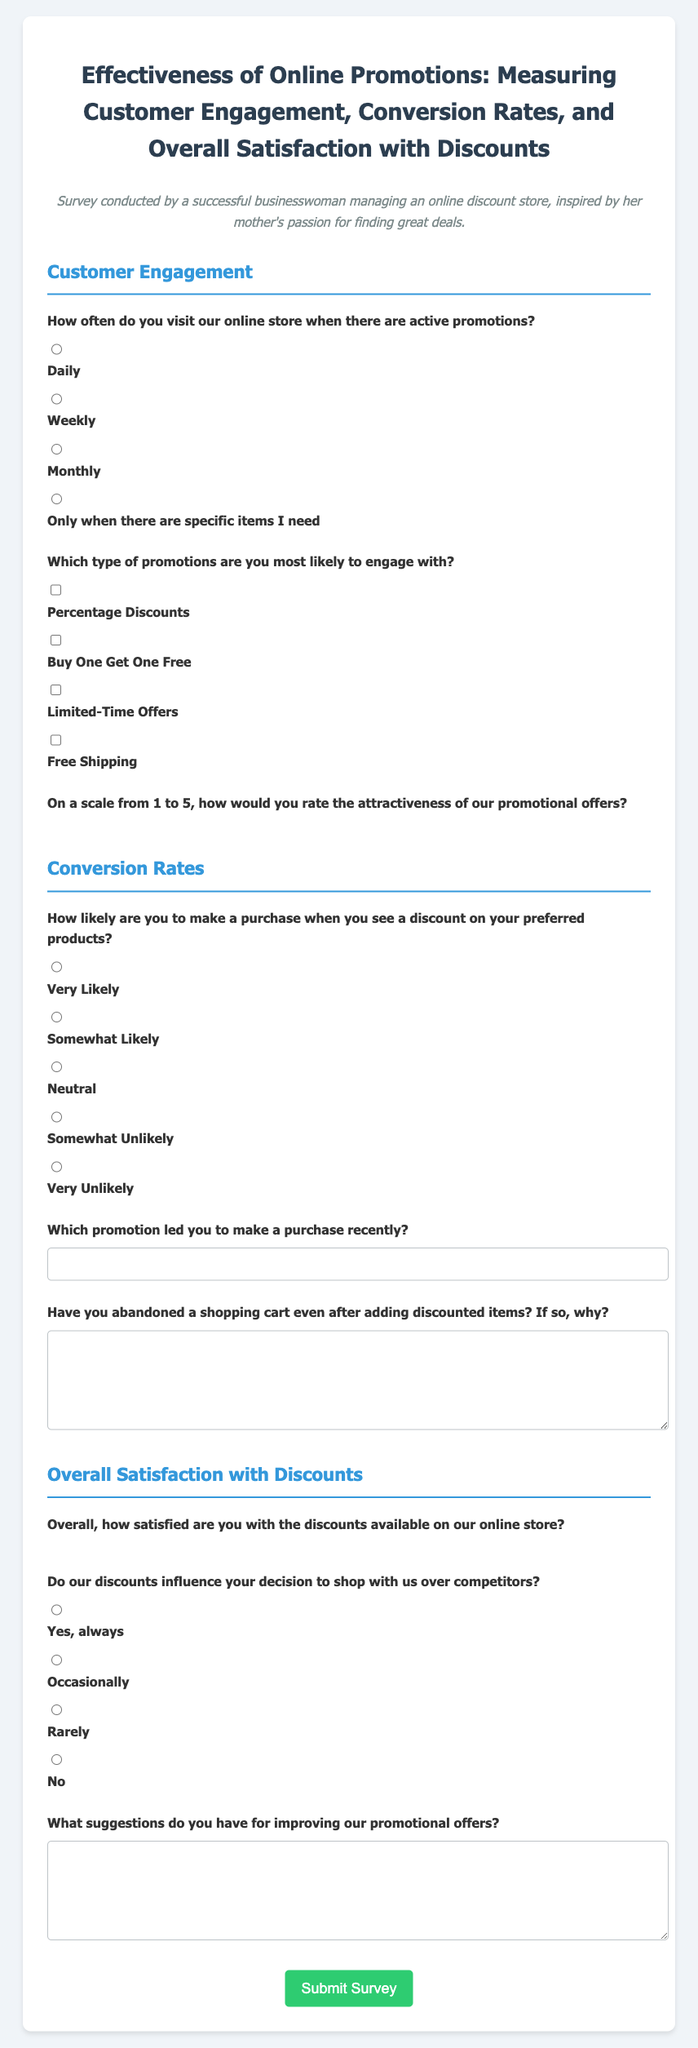What is the title of the survey? The title of the survey is mentioned at the beginning of the document.
Answer: Effectiveness of Online Promotions: Measuring Customer Engagement, Conversion Rates, and Overall Satisfaction with Discounts How often do customers visit the online store during promotions? The document lists options for how often customers visit the online store when there are active promotions.
Answer: Daily, Weekly, Monthly, Only when there are specific items I need What types of promotions can customers engage with? The document outlines different types of promotions that customers can select from.
Answer: Percentage Discounts, Buy One Get One Free, Limited-Time Offers, Free Shipping How likely are customers to make a purchase with discounts? The survey includes options for customers to rate their likelihood of making a purchase when seeing discounts.
Answer: Very Likely, Somewhat Likely, Neutral, Somewhat Unlikely, Very Unlikely On a scale of 1 to 5, how attractive are the promotional offers? The document asks customers to rate the attractiveness of the promotional offers on a scale from 1 to 5.
Answer: 1, 2, 3, 4, 5 How satisfied are customers with the discounts available? The document contains a question about overall satisfaction with discounts on the online store.
Answer: 1, 2, 3, 4, 5 Do discounts influence shopping decisions? The survey asks if discounts influence the decision to shop over competitors.
Answer: Yes, always; Occasionally; Rarely; No What suggestions do customers have for improving promotions? The document includes a question inviting suggestions for improving the promotional offers.
Answer: (Open-ended response) Which promotion led to the most recent purchase? The document includes a space for customers to indicate which promotion influenced their last purchase.
Answer: (Open-ended response) 